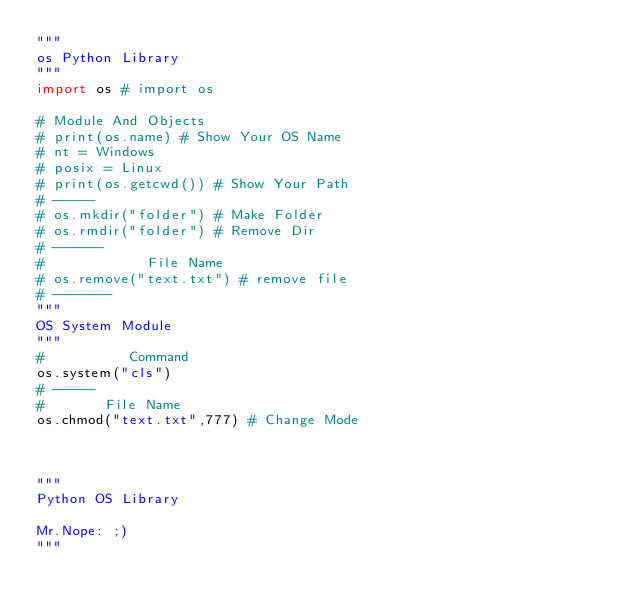Convert code to text. <code><loc_0><loc_0><loc_500><loc_500><_Python_>"""
os Python Library
"""
import os # import os

# Module And Objects
# print(os.name) # Show Your OS Name
# nt = Windows
# posix = Linux
# print(os.getcwd()) # Show Your Path
# -----
# os.mkdir("folder") # Make Folder
# os.rmdir("folder") # Remove Dir
# ------
#            File Name
# os.remove("text.txt") # remove file
# -------
"""
OS System Module
"""
#          Command
os.system("cls")
# -----
#       File Name
os.chmod("text.txt",777) # Change Mode



"""
Python OS Library

Mr.Nope: ;)
"""
</code> 